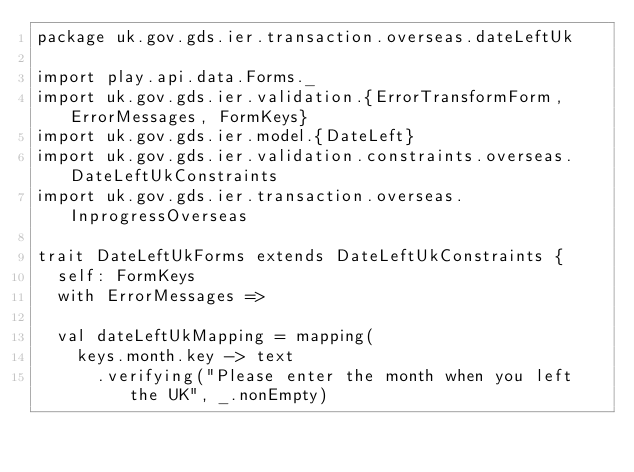<code> <loc_0><loc_0><loc_500><loc_500><_Scala_>package uk.gov.gds.ier.transaction.overseas.dateLeftUk

import play.api.data.Forms._
import uk.gov.gds.ier.validation.{ErrorTransformForm, ErrorMessages, FormKeys}
import uk.gov.gds.ier.model.{DateLeft}
import uk.gov.gds.ier.validation.constraints.overseas.DateLeftUkConstraints
import uk.gov.gds.ier.transaction.overseas.InprogressOverseas

trait DateLeftUkForms extends DateLeftUkConstraints {
  self: FormKeys
  with ErrorMessages =>

  val dateLeftUkMapping = mapping(
    keys.month.key -> text
      .verifying("Please enter the month when you left the UK", _.nonEmpty)</code> 